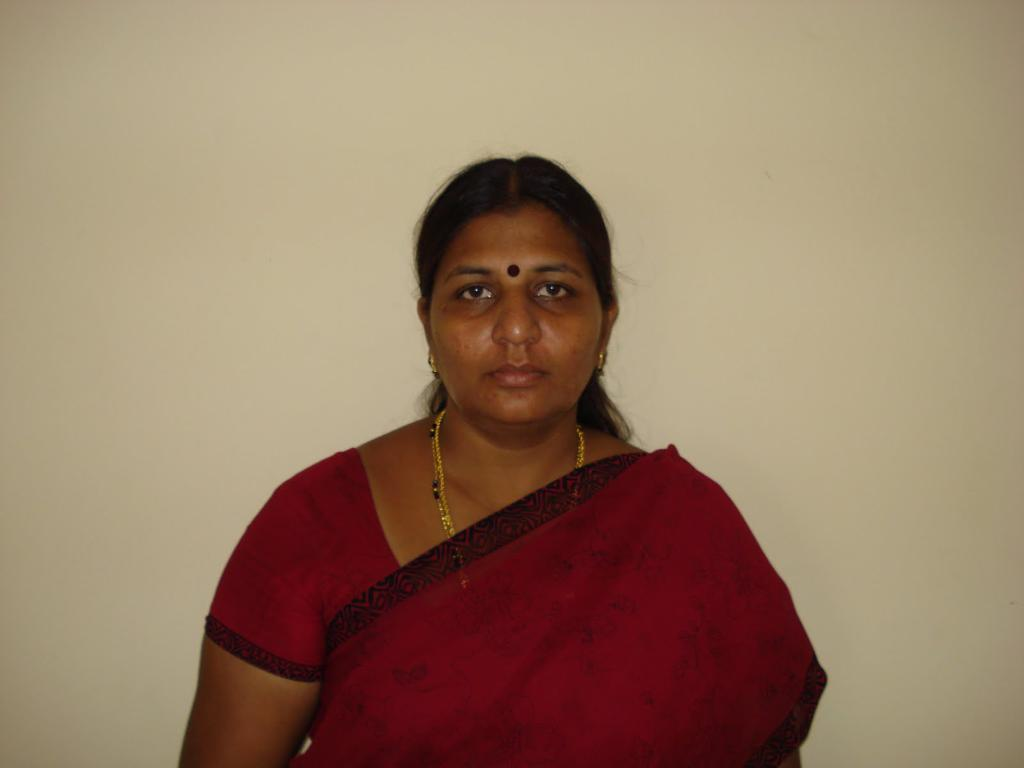What is the main subject of the image? There is a lady in the image. What is the lady wearing? The lady is wearing a red saree. What type of experience does the fireman have in the image? There is no fireman present in the image; it features a lady wearing a red saree. 